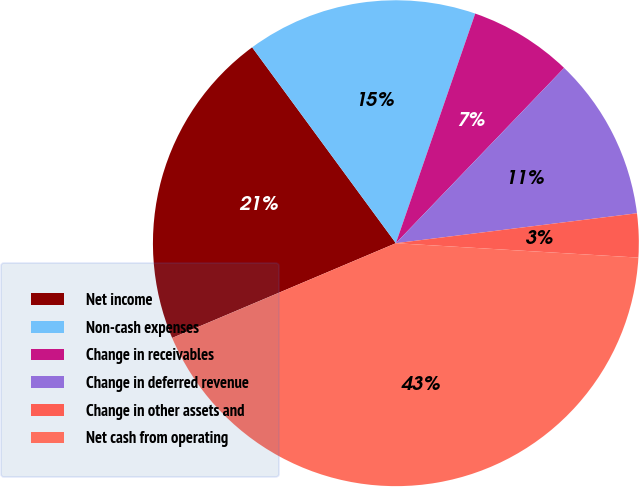<chart> <loc_0><loc_0><loc_500><loc_500><pie_chart><fcel>Net income<fcel>Non-cash expenses<fcel>Change in receivables<fcel>Change in deferred revenue<fcel>Change in other assets and<fcel>Net cash from operating<nl><fcel>21.3%<fcel>15.37%<fcel>6.88%<fcel>10.86%<fcel>2.91%<fcel>42.68%<nl></chart> 